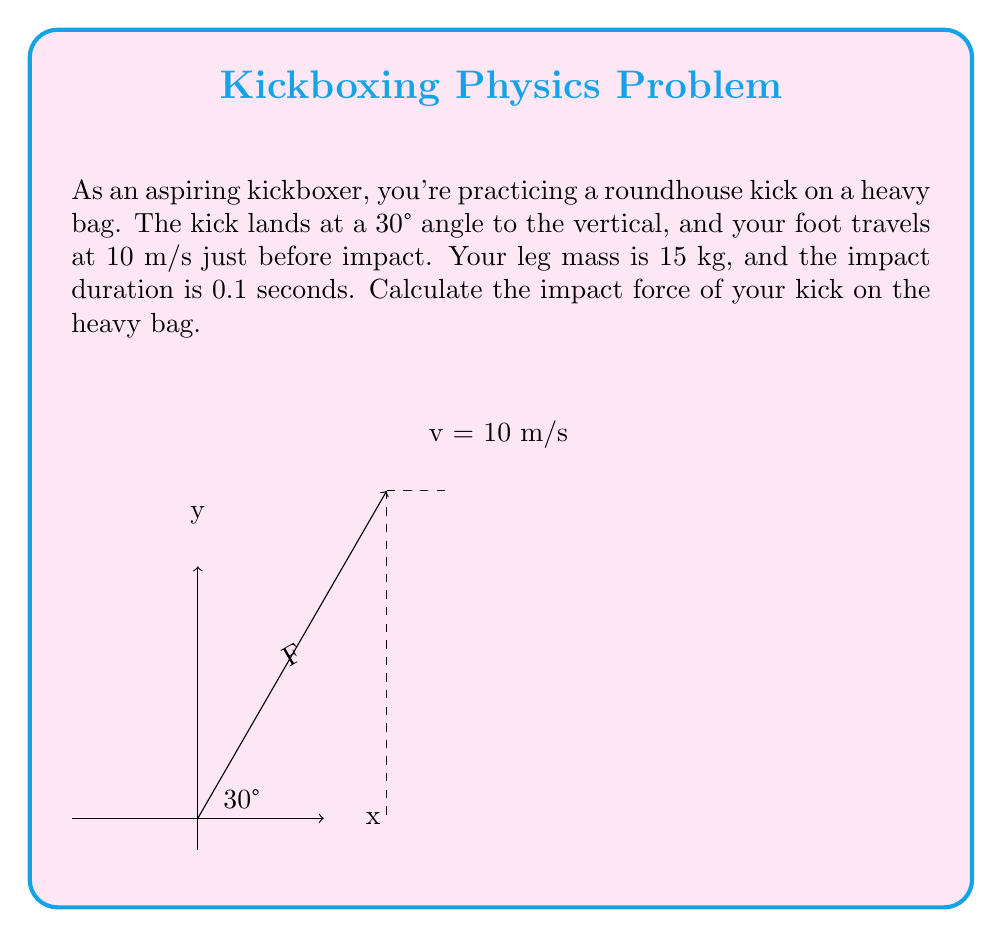Can you answer this question? Let's approach this step-by-step:

1) First, we need to find the change in momentum. The formula for momentum is:

   $$p = mv$$

   where $m$ is mass and $v$ is velocity.

2) The change in momentum is:

   $$\Delta p = m\Delta v$$

3) To find $\Delta v$, we need to consider the initial and final velocities:
   - Initial velocity: 10 m/s
   - Final velocity: 0 m/s (assuming the leg stops at impact)

   $$\Delta v = v_f - v_i = 0 - 10 = -10 \text{ m/s}$$

4) Now we can calculate the change in momentum:

   $$\Delta p = 15 \text{ kg} \cdot (-10 \text{ m/s}) = -150 \text{ kg·m/s}$$

5) The force is related to the change in momentum by the impulse-momentum theorem:

   $$F = \frac{\Delta p}{\Delta t}$$

   where $\Delta t$ is the impact duration.

6) Substituting our values:

   $$F = \frac{-150 \text{ kg·m/s}}{0.1 \text{ s}} = -1500 \text{ N}$$

7) This force is along the direction of the kick. To find the force perpendicular to the bag (impact force), we need to consider the angle:

   $$F_{\text{impact}} = F \cos(30°) = -1500 \cdot \cos(30°) = -1299.04 \text{ N}$$

8) The negative sign indicates the direction of the force (into the bag). The magnitude of the impact force is 1299.04 N.
Answer: 1299.04 N 